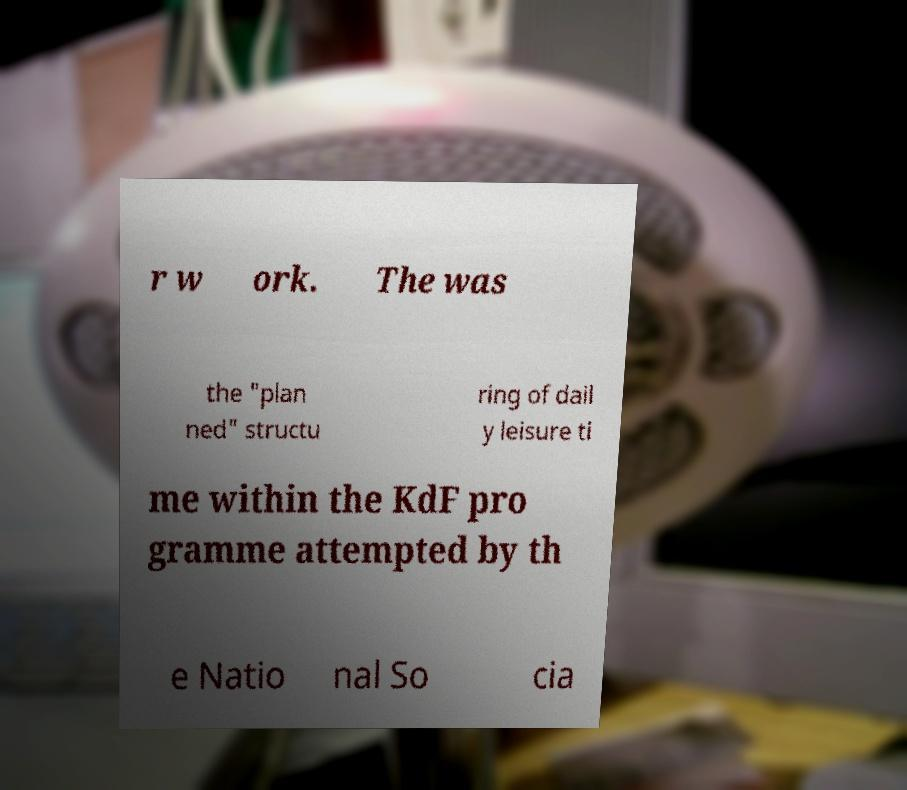Can you accurately transcribe the text from the provided image for me? r w ork. The was the "plan ned" structu ring of dail y leisure ti me within the KdF pro gramme attempted by th e Natio nal So cia 